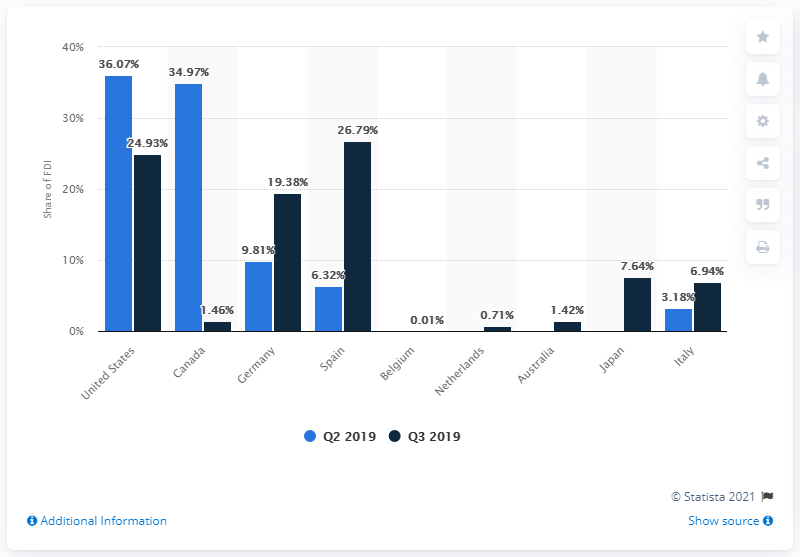Mention a couple of crucial points in this snapshot. In the third quarter of 2019, less than one-third of the foreign direct investment in Mexico came from the United States. According to data, nearly 27% of Mexican FDI originated from Spain, a significant percentage of the total FDI received by Mexico. 